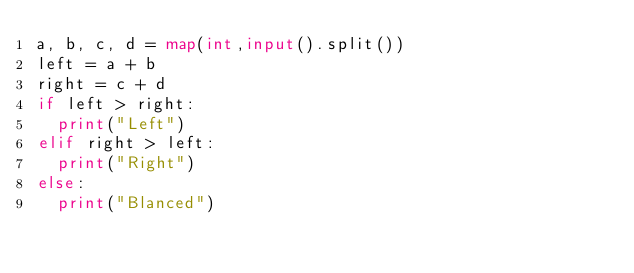Convert code to text. <code><loc_0><loc_0><loc_500><loc_500><_Python_>a, b, c, d = map(int,input().split())
left = a + b
right = c + d
if left > right:
  print("Left")  
elif right > left:
  print("Right")
else:
  print("Blanced")</code> 